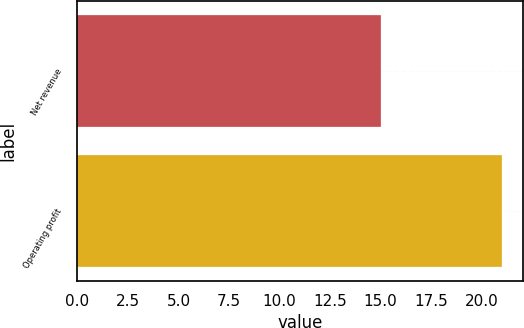<chart> <loc_0><loc_0><loc_500><loc_500><bar_chart><fcel>Net revenue<fcel>Operating profit<nl><fcel>15<fcel>21<nl></chart> 